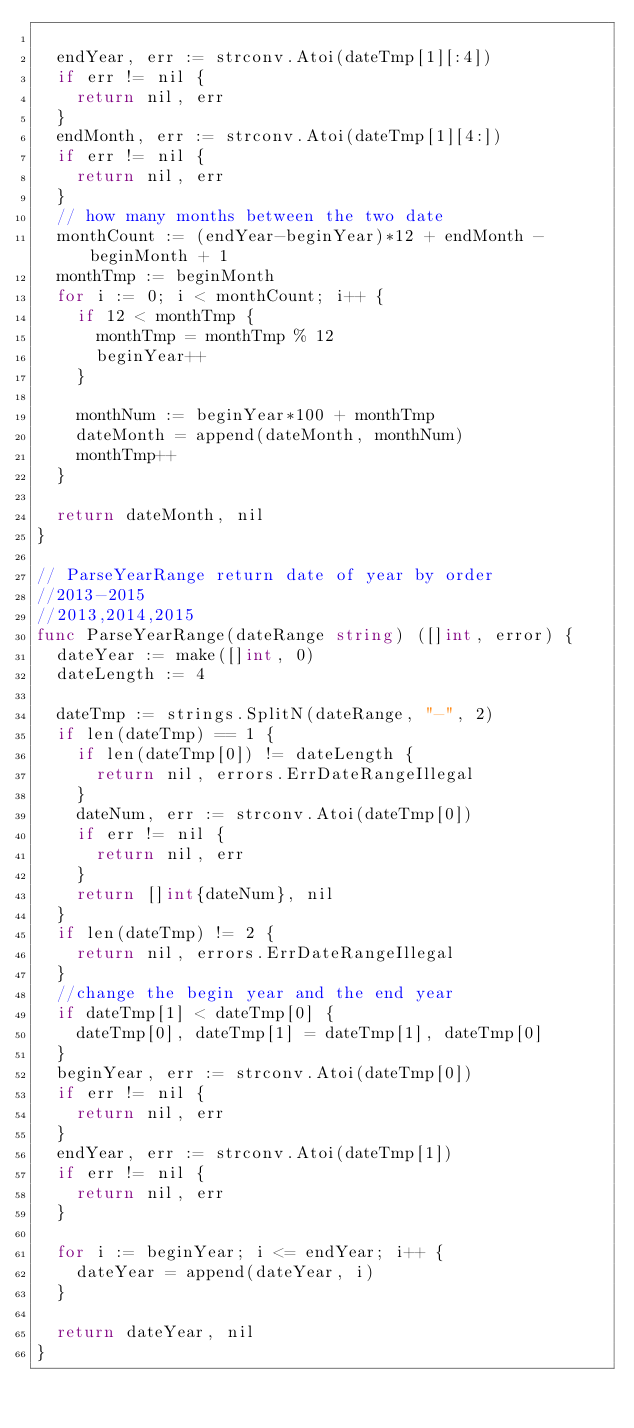Convert code to text. <code><loc_0><loc_0><loc_500><loc_500><_Go_>
	endYear, err := strconv.Atoi(dateTmp[1][:4])
	if err != nil {
		return nil, err
	}
	endMonth, err := strconv.Atoi(dateTmp[1][4:])
	if err != nil {
		return nil, err
	}
	// how many months between the two date
	monthCount := (endYear-beginYear)*12 + endMonth - beginMonth + 1
	monthTmp := beginMonth
	for i := 0; i < monthCount; i++ {
		if 12 < monthTmp {
			monthTmp = monthTmp % 12
			beginYear++
		}

		monthNum := beginYear*100 + monthTmp
		dateMonth = append(dateMonth, monthNum)
		monthTmp++
	}

	return dateMonth, nil
}

// ParseYearRange return date of year by order
//2013-2015
//2013,2014,2015
func ParseYearRange(dateRange string) ([]int, error) {
	dateYear := make([]int, 0)
	dateLength := 4

	dateTmp := strings.SplitN(dateRange, "-", 2)
	if len(dateTmp) == 1 {
		if len(dateTmp[0]) != dateLength {
			return nil, errors.ErrDateRangeIllegal
		}
		dateNum, err := strconv.Atoi(dateTmp[0])
		if err != nil {
			return nil, err
		}
		return []int{dateNum}, nil
	}
	if len(dateTmp) != 2 {
		return nil, errors.ErrDateRangeIllegal
	}
	//change the begin year and the end year
	if dateTmp[1] < dateTmp[0] {
		dateTmp[0], dateTmp[1] = dateTmp[1], dateTmp[0]
	}
	beginYear, err := strconv.Atoi(dateTmp[0])
	if err != nil {
		return nil, err
	}
	endYear, err := strconv.Atoi(dateTmp[1])
	if err != nil {
		return nil, err
	}

	for i := beginYear; i <= endYear; i++ {
		dateYear = append(dateYear, i)
	}

	return dateYear, nil
}
</code> 